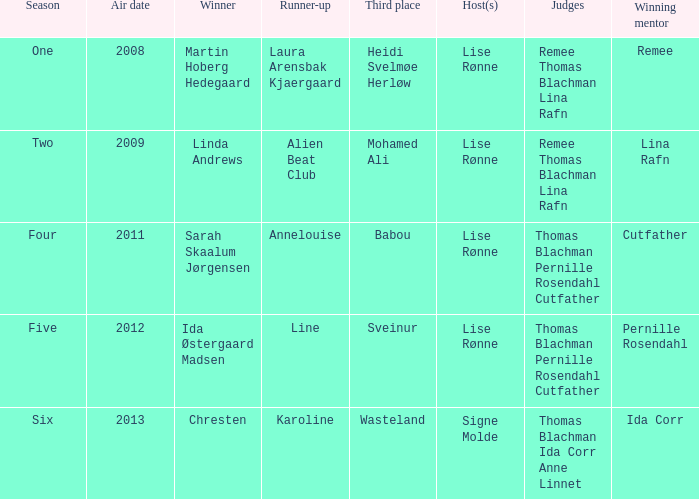Who was the runner-up when Mohamed Ali got third? Alien Beat Club. 